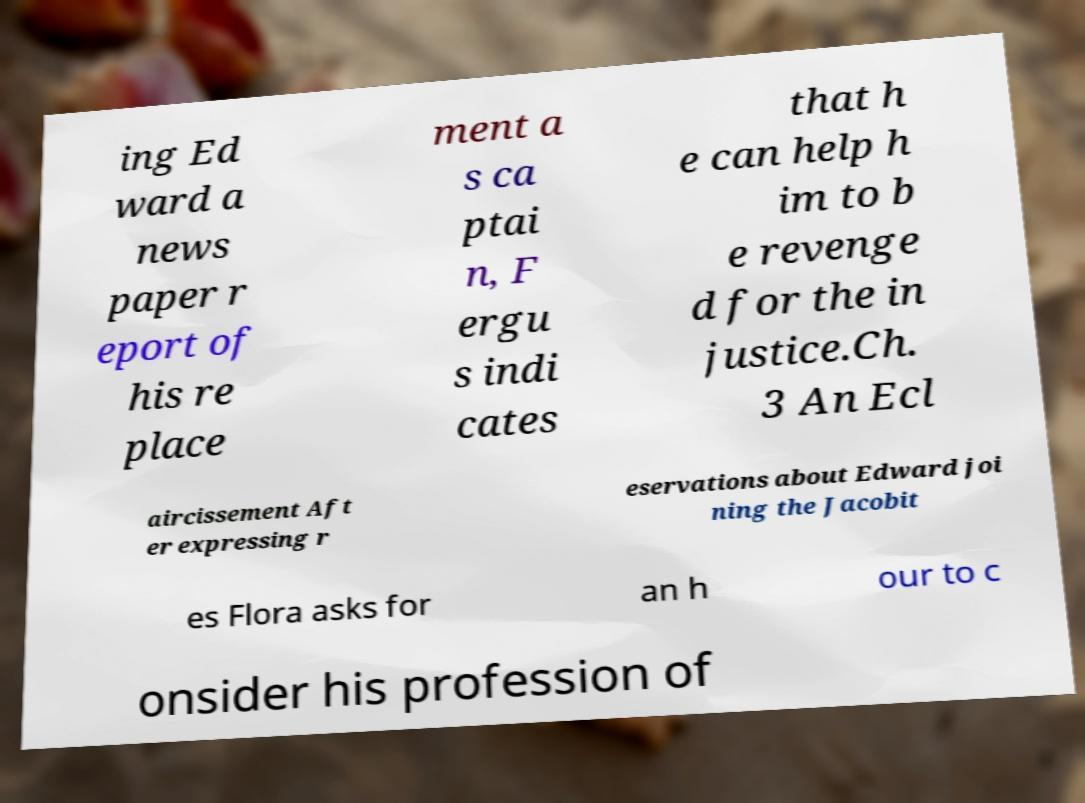I need the written content from this picture converted into text. Can you do that? ing Ed ward a news paper r eport of his re place ment a s ca ptai n, F ergu s indi cates that h e can help h im to b e revenge d for the in justice.Ch. 3 An Ecl aircissement Aft er expressing r eservations about Edward joi ning the Jacobit es Flora asks for an h our to c onsider his profession of 